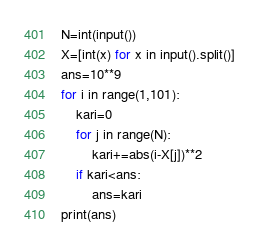Convert code to text. <code><loc_0><loc_0><loc_500><loc_500><_Python_>N=int(input())
X=[int(x) for x in input().split()]
ans=10**9
for i in range(1,101):
    kari=0
    for j in range(N):
        kari+=abs(i-X[j])**2
    if kari<ans:
        ans=kari
print(ans)
</code> 